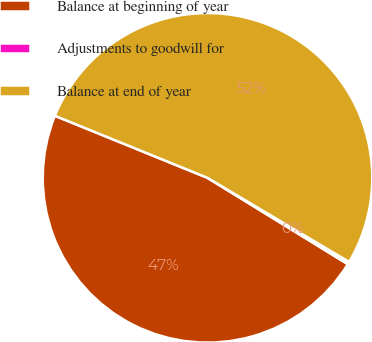Convert chart to OTSL. <chart><loc_0><loc_0><loc_500><loc_500><pie_chart><fcel>Balance at beginning of year<fcel>Adjustments to goodwill for<fcel>Balance at end of year<nl><fcel>47.37%<fcel>0.25%<fcel>52.38%<nl></chart> 